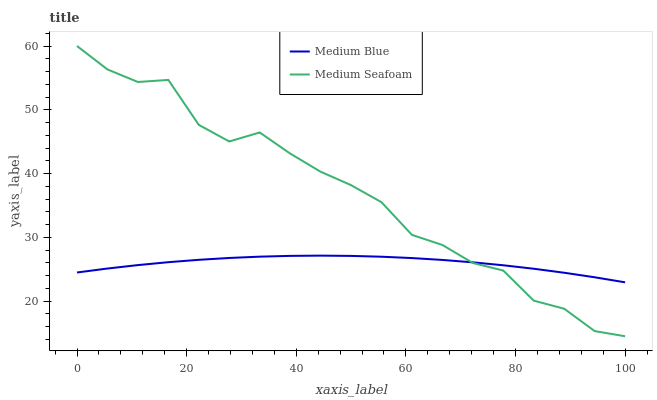Does Medium Blue have the minimum area under the curve?
Answer yes or no. Yes. Does Medium Seafoam have the maximum area under the curve?
Answer yes or no. Yes. Does Medium Seafoam have the minimum area under the curve?
Answer yes or no. No. Is Medium Blue the smoothest?
Answer yes or no. Yes. Is Medium Seafoam the roughest?
Answer yes or no. Yes. Is Medium Seafoam the smoothest?
Answer yes or no. No. Does Medium Seafoam have the highest value?
Answer yes or no. Yes. Does Medium Seafoam intersect Medium Blue?
Answer yes or no. Yes. Is Medium Seafoam less than Medium Blue?
Answer yes or no. No. Is Medium Seafoam greater than Medium Blue?
Answer yes or no. No. 